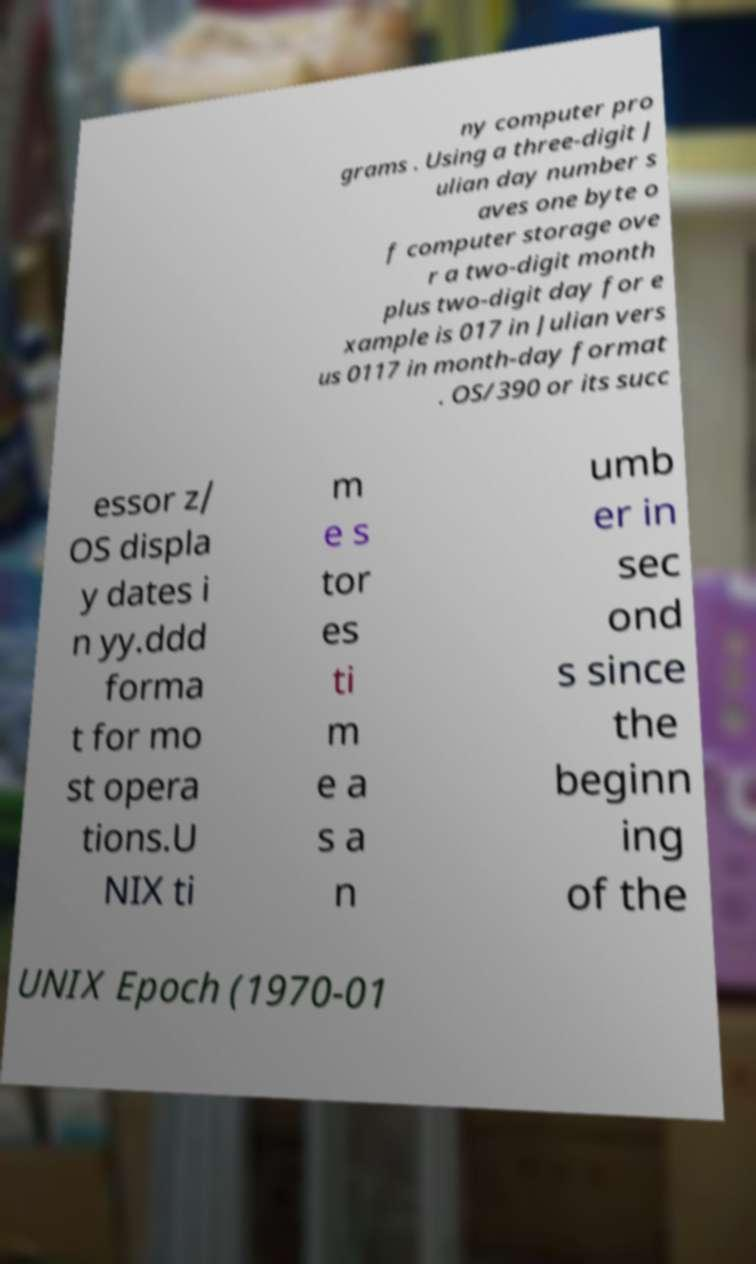I need the written content from this picture converted into text. Can you do that? ny computer pro grams . Using a three-digit J ulian day number s aves one byte o f computer storage ove r a two-digit month plus two-digit day for e xample is 017 in Julian vers us 0117 in month-day format . OS/390 or its succ essor z/ OS displa y dates i n yy.ddd forma t for mo st opera tions.U NIX ti m e s tor es ti m e a s a n umb er in sec ond s since the beginn ing of the UNIX Epoch (1970-01 